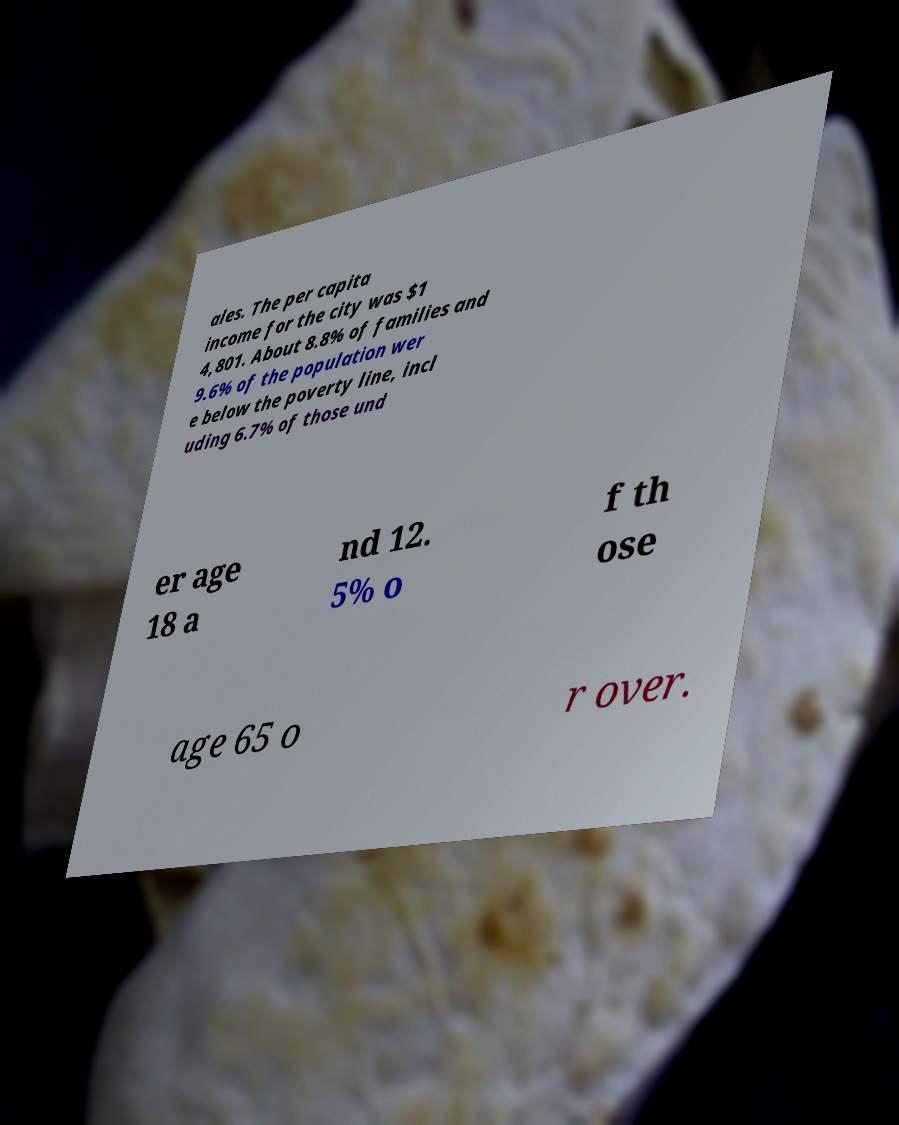I need the written content from this picture converted into text. Can you do that? ales. The per capita income for the city was $1 4,801. About 8.8% of families and 9.6% of the population wer e below the poverty line, incl uding 6.7% of those und er age 18 a nd 12. 5% o f th ose age 65 o r over. 